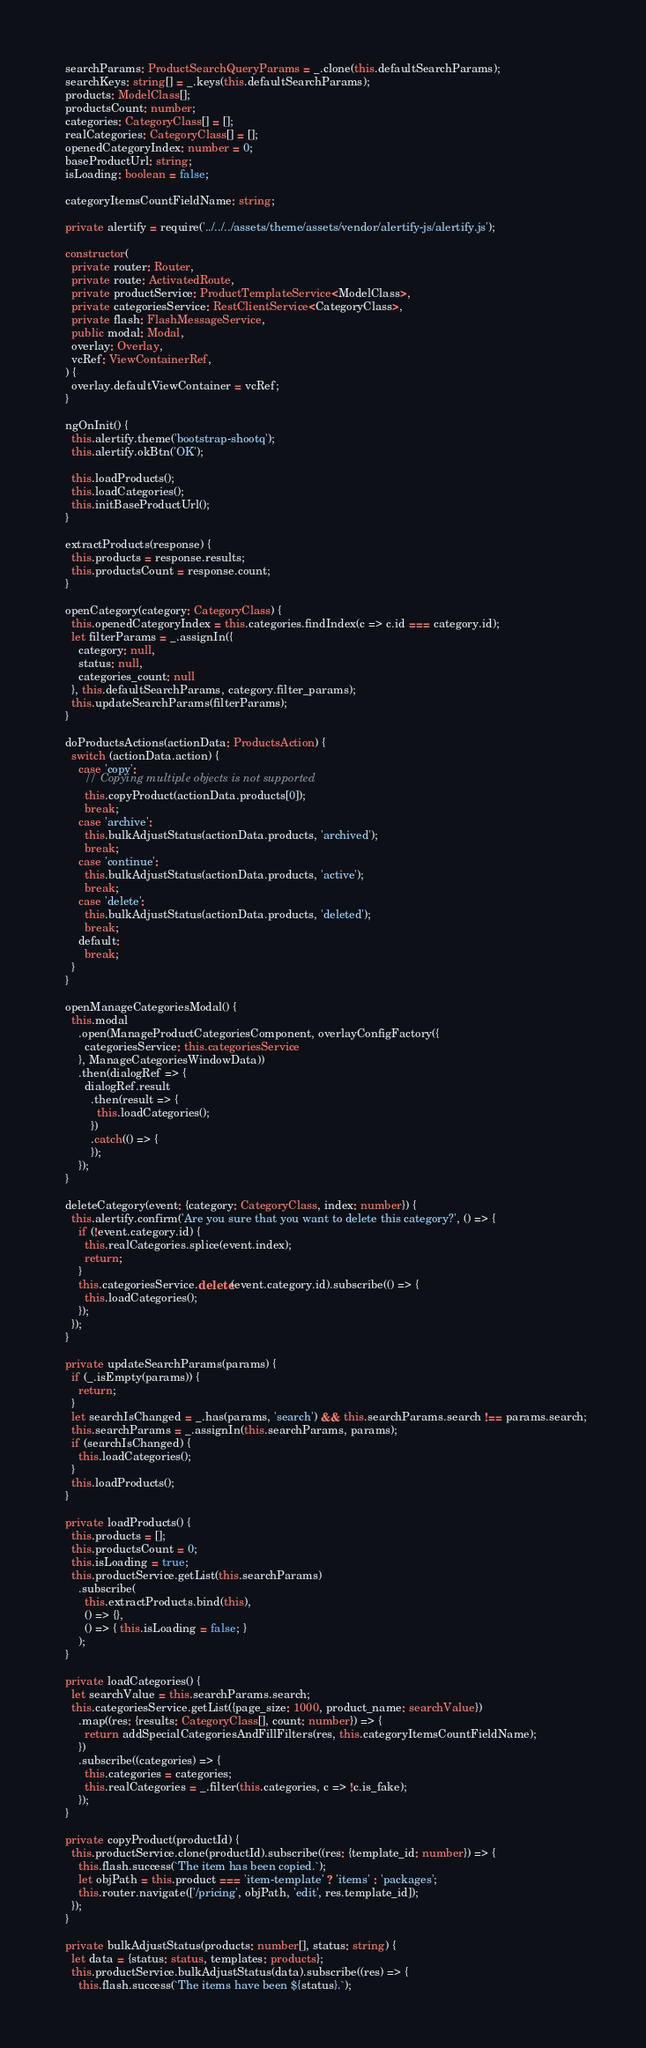Convert code to text. <code><loc_0><loc_0><loc_500><loc_500><_TypeScript_>  searchParams: ProductSearchQueryParams = _.clone(this.defaultSearchParams);
  searchKeys: string[] = _.keys(this.defaultSearchParams);
  products: ModelClass[];
  productsCount: number;
  categories: CategoryClass[] = [];
  realCategories: CategoryClass[] = [];
  openedCategoryIndex: number = 0;
  baseProductUrl: string;
  isLoading: boolean = false;

  categoryItemsCountFieldName: string;

  private alertify = require('../../../assets/theme/assets/vendor/alertify-js/alertify.js');

  constructor(
    private router: Router,
    private route: ActivatedRoute,
    private productService: ProductTemplateService<ModelClass>,
    private categoriesService: RestClientService<CategoryClass>,
    private flash: FlashMessageService,
    public modal: Modal,
    overlay: Overlay,
    vcRef: ViewContainerRef,
  ) {
    overlay.defaultViewContainer = vcRef;
  }

  ngOnInit() {
    this.alertify.theme('bootstrap-shootq');
    this.alertify.okBtn('OK');

    this.loadProducts();
    this.loadCategories();
    this.initBaseProductUrl();
  }

  extractProducts(response) {
    this.products = response.results;
    this.productsCount = response.count;
  }

  openCategory(category: CategoryClass) {
    this.openedCategoryIndex = this.categories.findIndex(c => c.id === category.id);
    let filterParams = _.assignIn({
      category: null,
      status: null,
      categories_count: null
    }, this.defaultSearchParams, category.filter_params);
    this.updateSearchParams(filterParams);
  }

  doProductsActions(actionData: ProductsAction) {
    switch (actionData.action) {
      case 'copy':
        // Copying multiple objects is not supported
        this.copyProduct(actionData.products[0]);
        break;
      case 'archive':
        this.bulkAdjustStatus(actionData.products, 'archived');
        break;
      case 'continue':
        this.bulkAdjustStatus(actionData.products, 'active');
        break;
      case 'delete':
        this.bulkAdjustStatus(actionData.products, 'deleted');
        break;
      default:
        break;
    }
  }

  openManageCategoriesModal() {
    this.modal
      .open(ManageProductCategoriesComponent, overlayConfigFactory({
        categoriesService: this.categoriesService
      }, ManageCategoriesWindowData))
      .then(dialogRef => {
        dialogRef.result
          .then(result => {
            this.loadCategories();
          })
          .catch(() => {
          });
      });
  }

  deleteCategory(event: {category: CategoryClass, index: number}) {
    this.alertify.confirm('Are you sure that you want to delete this category?', () => {
      if (!event.category.id) {
        this.realCategories.splice(event.index);
        return;
      }
      this.categoriesService.delete(event.category.id).subscribe(() => {
        this.loadCategories();
      });
    });
  }

  private updateSearchParams(params) {
    if (_.isEmpty(params)) {
      return;
    }
    let searchIsChanged = _.has(params, 'search') && this.searchParams.search !== params.search;
    this.searchParams = _.assignIn(this.searchParams, params);
    if (searchIsChanged) {
      this.loadCategories();
    }
    this.loadProducts();
  }

  private loadProducts() {
    this.products = [];
    this.productsCount = 0;
    this.isLoading = true;
    this.productService.getList(this.searchParams)
      .subscribe(
        this.extractProducts.bind(this),
        () => {},
        () => { this.isLoading = false; }
      );
  }

  private loadCategories() {
    let searchValue = this.searchParams.search;
    this.categoriesService.getList({page_size: 1000, product_name: searchValue})
      .map((res: {results: CategoryClass[], count: number}) => {
        return addSpecialCategoriesAndFillFilters(res, this.categoryItemsCountFieldName);
      })
      .subscribe((categories) => {
        this.categories = categories;
        this.realCategories = _.filter(this.categories, c => !c.is_fake);
      });
  }

  private copyProduct(productId) {
    this.productService.clone(productId).subscribe((res: {template_id: number}) => {
      this.flash.success(`The item has been copied.`);
      let objPath = this.product === 'item-template' ? 'items' : 'packages';
      this.router.navigate(['/pricing', objPath, 'edit', res.template_id]);
    });
  }

  private bulkAdjustStatus(products: number[], status: string) {
    let data = {status: status, templates: products};
    this.productService.bulkAdjustStatus(data).subscribe((res) => {
      this.flash.success(`The items have been ${status}.`);</code> 